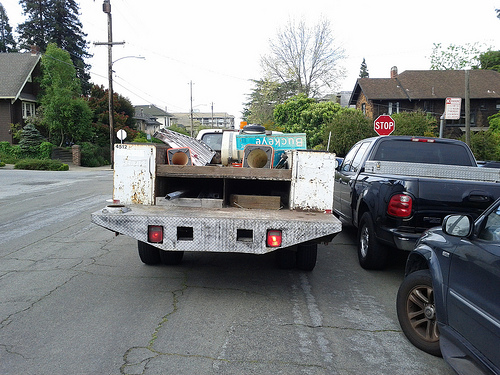What items can you see on the back of the truck? On the back of the truck, there are several items, including a mattress, a ladder, metal cans, and what appears to be a tire amongst other miscellaneous objects. It looks like a collection of used or discarded items, possibly for disposal or recycling. 